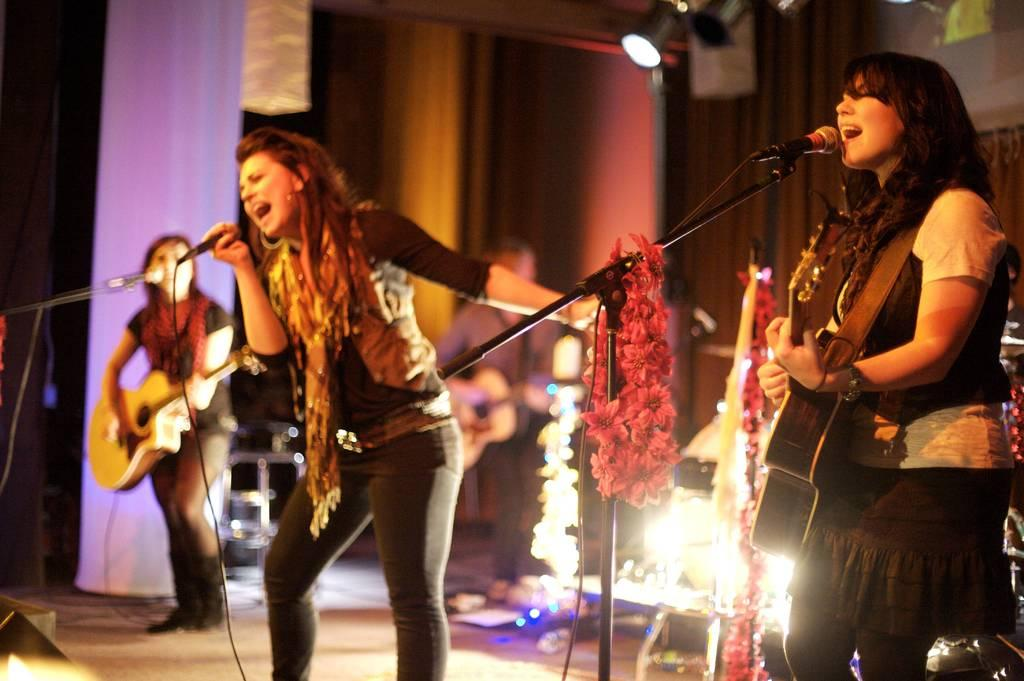What can be observed about the people in the image? There are people in the image, and some of them are holding guitars. Can you describe the woman in the image? The woman in the image is holding a microphone. What is the presence of mice in the image? There are mice in front of the people in the image. What type of debt is being discussed by the people in the image? There is no indication of any debt being discussed in the image; the focus is on the people holding guitars and the woman with a microphone. Can you tell me how many beetles are present in the image? There are no beetles present in the image; the focus is on the people, the woman, and the mice. 